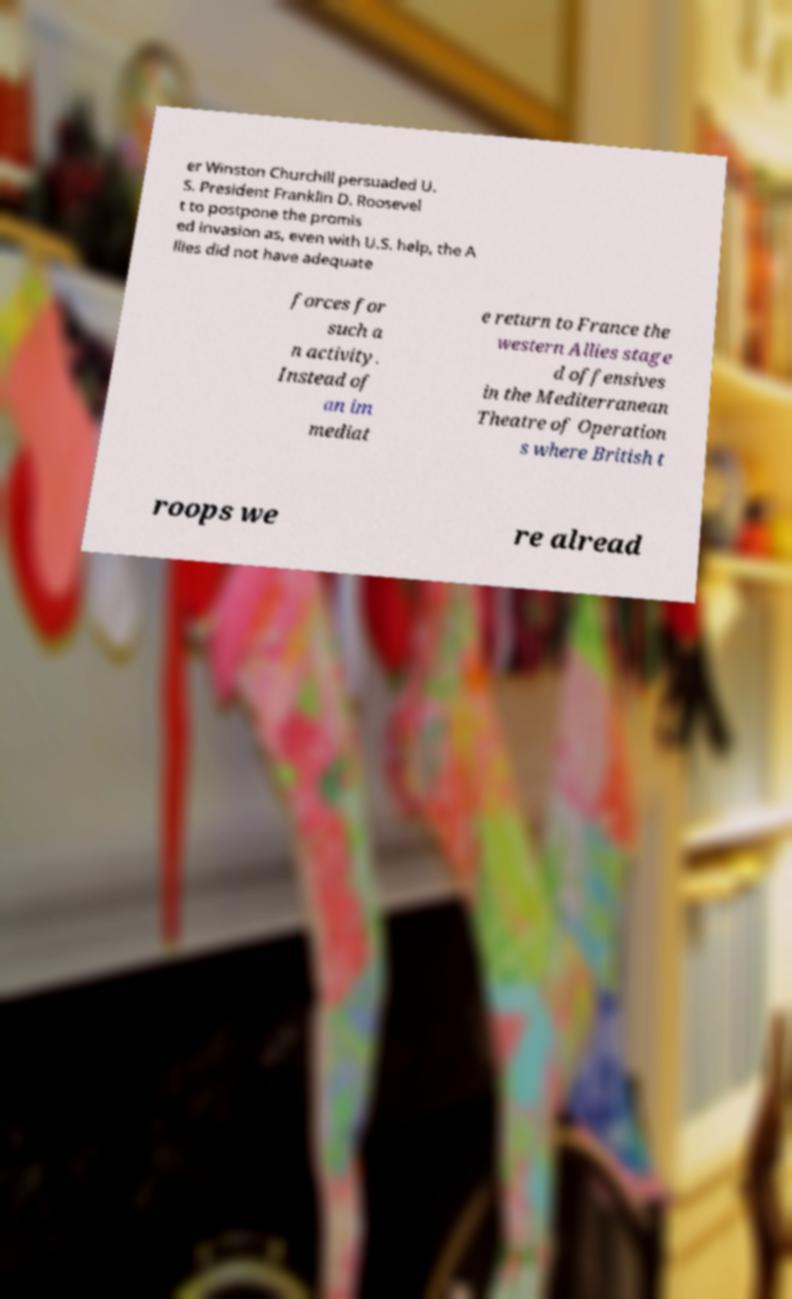Could you extract and type out the text from this image? er Winston Churchill persuaded U. S. President Franklin D. Roosevel t to postpone the promis ed invasion as, even with U.S. help, the A llies did not have adequate forces for such a n activity. Instead of an im mediat e return to France the western Allies stage d offensives in the Mediterranean Theatre of Operation s where British t roops we re alread 